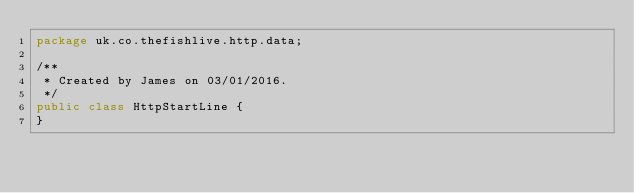Convert code to text. <code><loc_0><loc_0><loc_500><loc_500><_Java_>package uk.co.thefishlive.http.data;

/**
 * Created by James on 03/01/2016.
 */
public class HttpStartLine {
}
</code> 